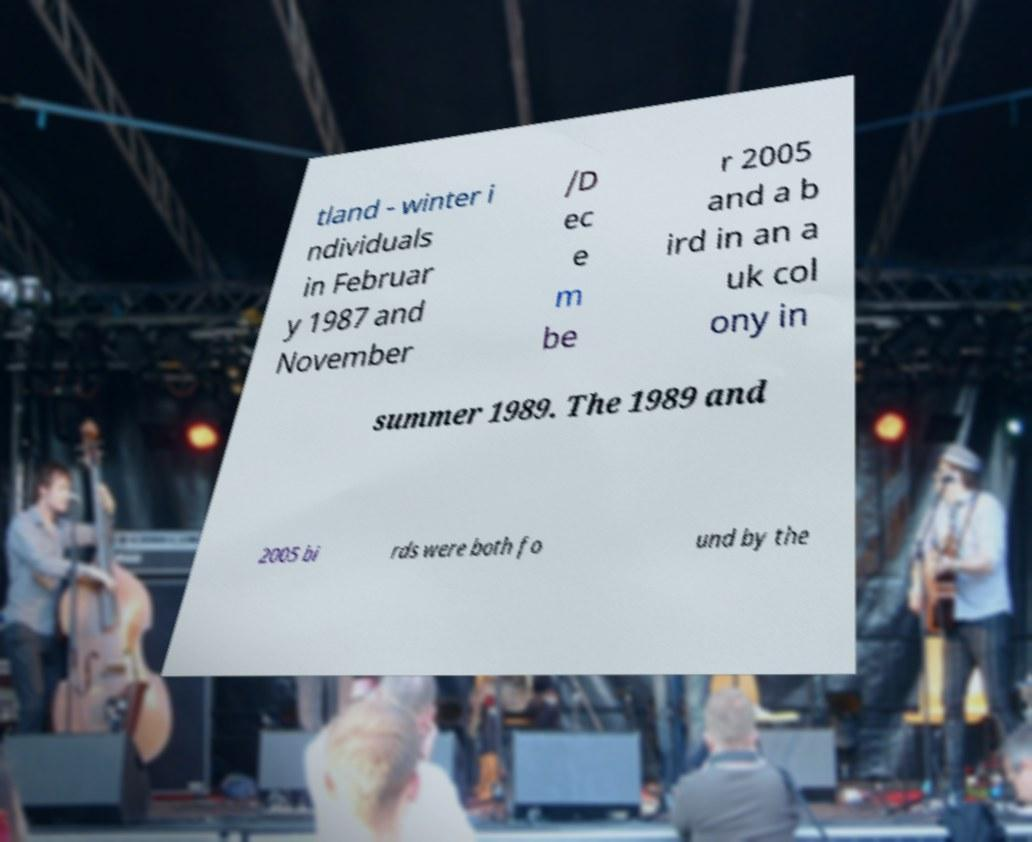There's text embedded in this image that I need extracted. Can you transcribe it verbatim? tland - winter i ndividuals in Februar y 1987 and November /D ec e m be r 2005 and a b ird in an a uk col ony in summer 1989. The 1989 and 2005 bi rds were both fo und by the 